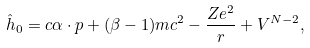<formula> <loc_0><loc_0><loc_500><loc_500>\hat { h } _ { 0 } = c \alpha \cdot p + ( \beta - 1 ) m c ^ { 2 } - \frac { Z e ^ { 2 } } { r } + V ^ { N - 2 } ,</formula> 